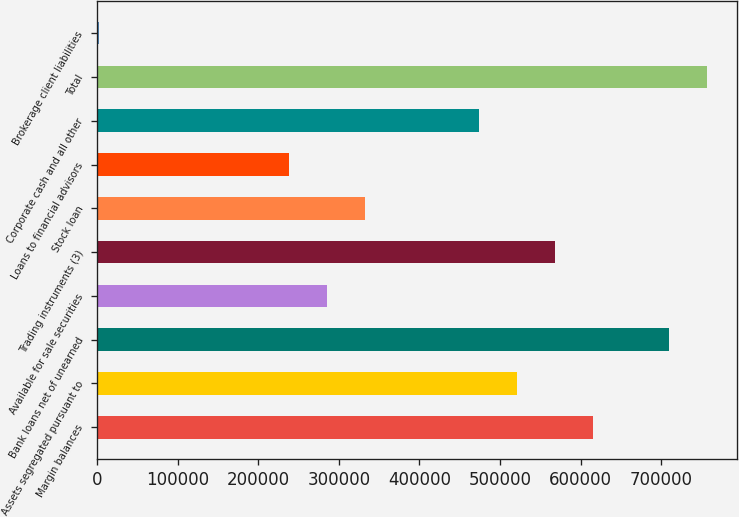<chart> <loc_0><loc_0><loc_500><loc_500><bar_chart><fcel>Margin balances<fcel>Assets segregated pursuant to<fcel>Bank loans net of unearned<fcel>Available for sale securities<fcel>Trading instruments (3)<fcel>Stock loan<fcel>Loans to financial advisors<fcel>Corporate cash and all other<fcel>Total<fcel>Brokerage client liabilities<nl><fcel>615064<fcel>520754<fcel>709374<fcel>284979<fcel>567909<fcel>332134<fcel>237824<fcel>473599<fcel>756529<fcel>2049<nl></chart> 